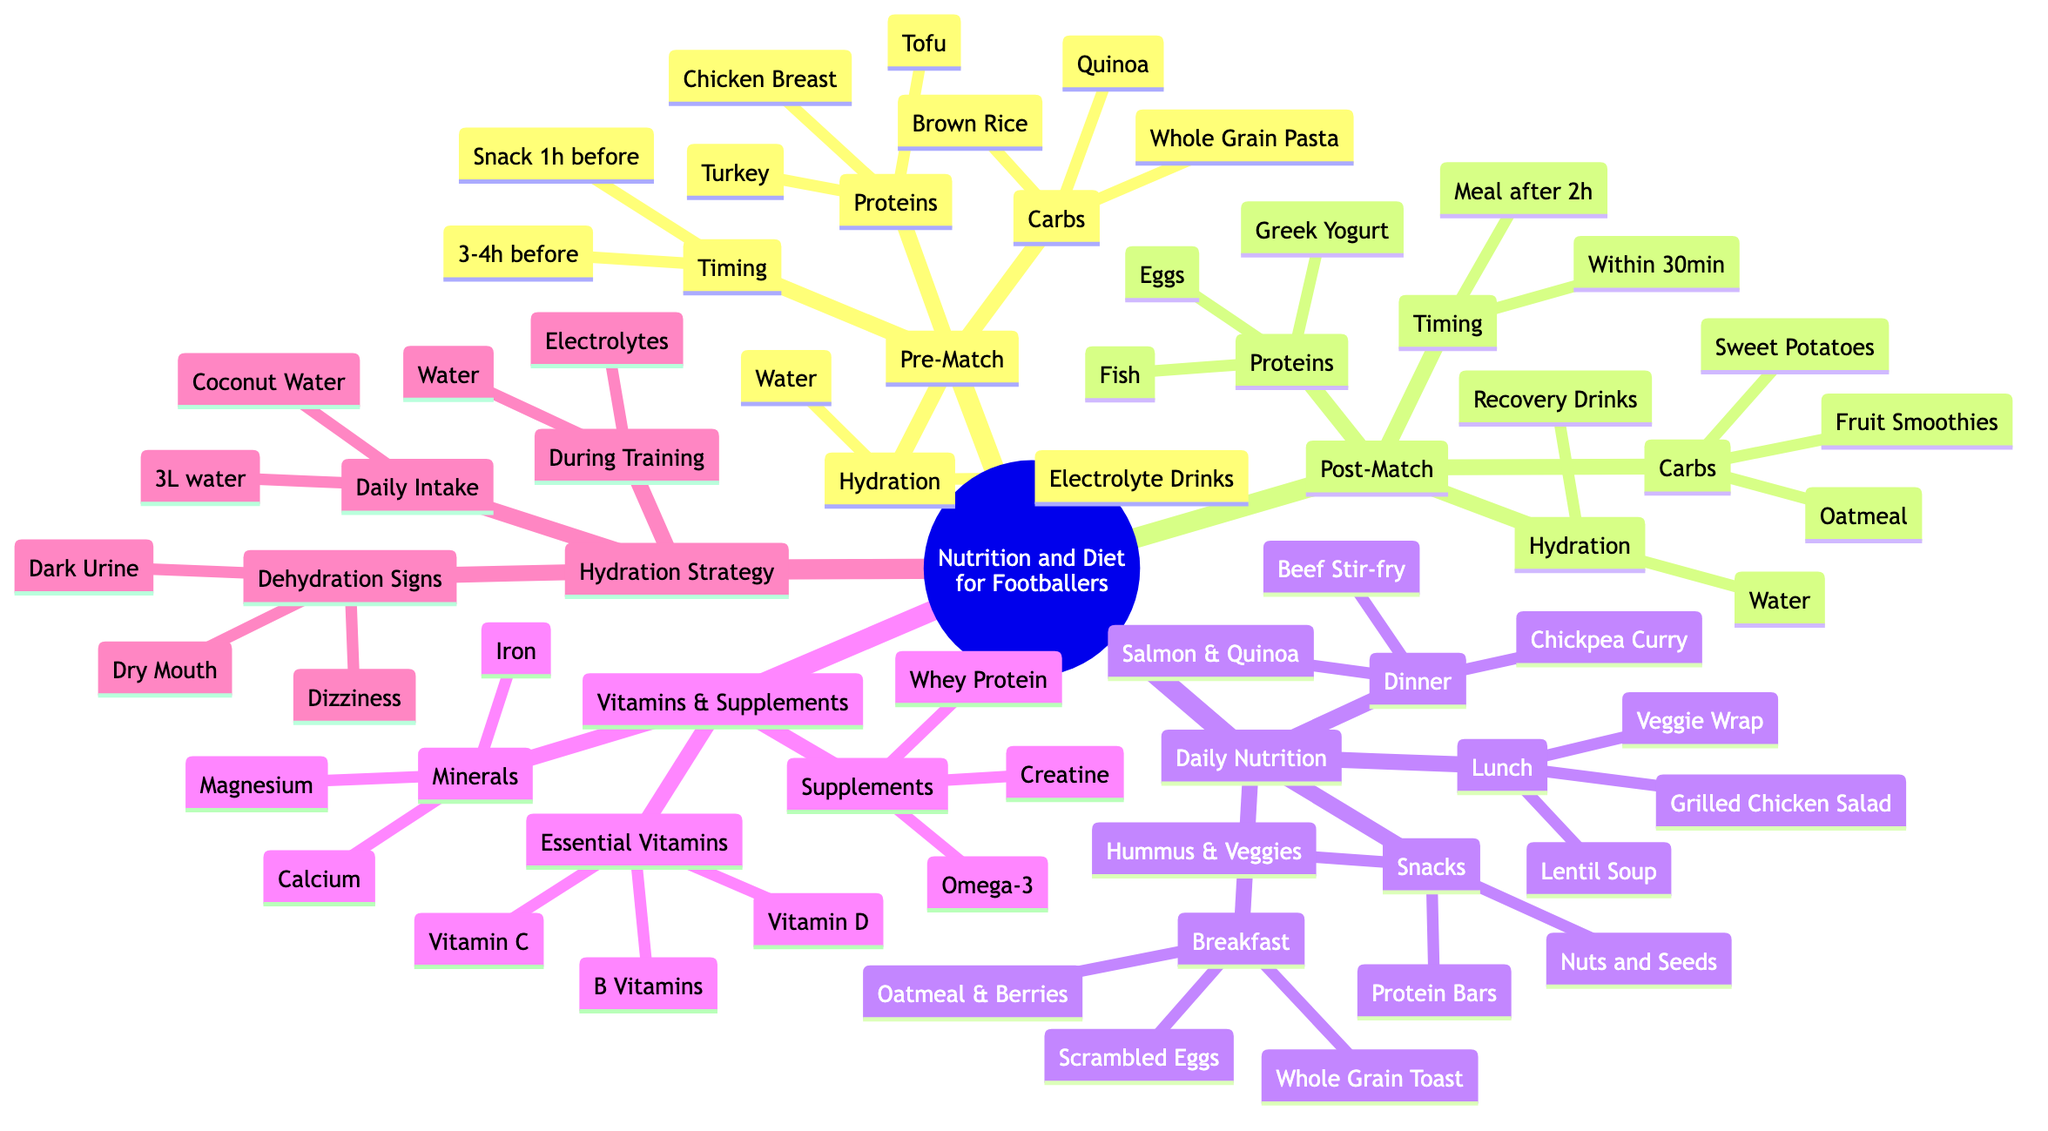What are the three types of nutrients listed under Pre-Match Nutrition? The diagram shows three subcategories under Pre-Match Nutrition: Carbohydrates, Proteins, and Hydration.
Answer: Carbohydrates, Proteins, Hydration How long before a match should a footballer eat a small snack? According to the Timing section under Pre-Match Nutrition, a small snack should be consumed 1 hour before the match.
Answer: 1 hour Which food item is listed as a carbohydrate source for post-match recovery? Looking at the Post-Match Recovery section, one of the carbohydrate sources listed is Sweet Potatoes.
Answer: Sweet Potatoes What are the two hydration strategies mentioned during training? The diagram indicates two hydration sources during training: Water and Electrolyte Solutions.
Answer: Water, Electrolyte Solutions How many essential vitamins are listed under Vitamins and Supplements? Under Essential Vitamins, there are three vitamins mentioned: Vitamin D, Vitamin C, and B Vitamins. This totals three vitamins.
Answer: 3 Which food is suggested for breakfast that includes fruit? The Daily Nutrition section lists Oatmeal with Berries as a breakfast option that includes fruit.
Answer: Oatmeal with Berries Name one sign of dehydration according to the Hydration Strategy. The diagram identifies Dark Urine as one of the signs of dehydration under Hydration Strategy.
Answer: Dark Urine What is the recommended daily fluid intake for a footballer? The Daily Fluid Intake section specifies that a footballer should consume 3 liters of water daily.
Answer: 3 liters What type of protein is suggested as a post-match recovery food? The Post-Match Recovery section presents Fish as one of the protein options for recovery after a match.
Answer: Fish 